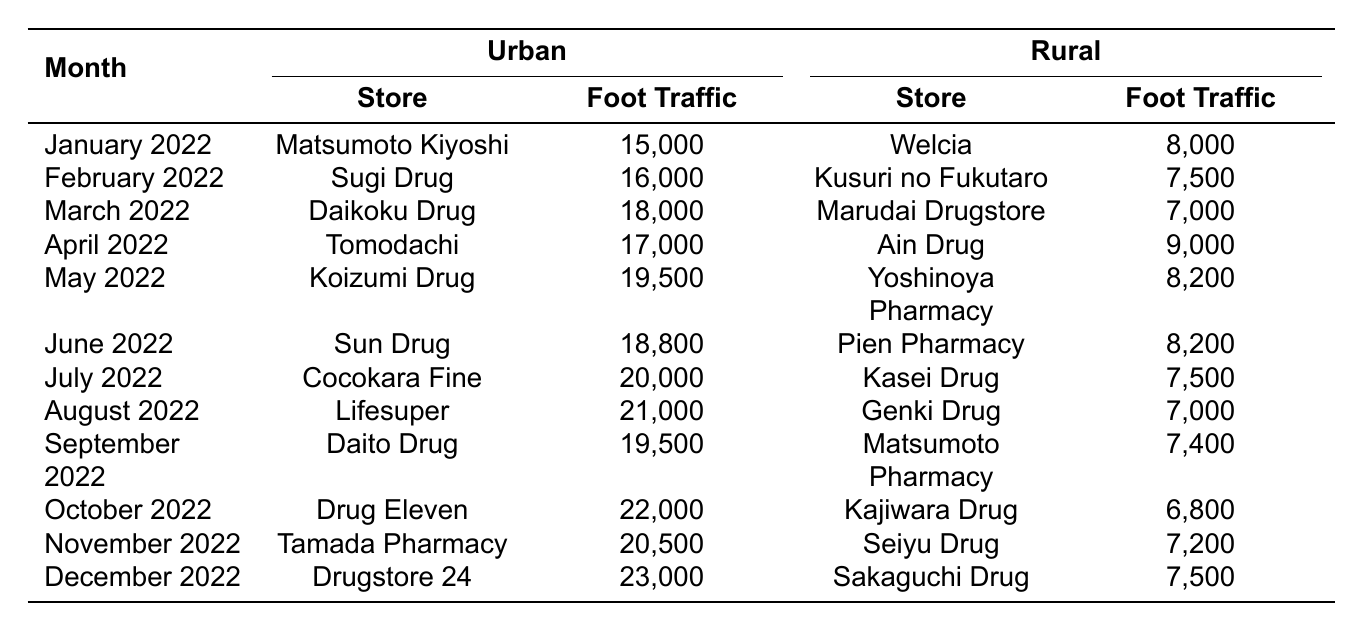What was the foot traffic of Cocokara Fine in July 2022? In the table, under July 2022 in the urban section, Cocokara Fine's foot traffic is listed as 20,000.
Answer: 20,000 Which rural drugstore had the highest foot traffic in December 2022? In December 2022, the rural drugstore Sakaguchi Drug had a foot traffic of 7,500, which is the highest for that month among rural stores listed.
Answer: Sakaguchi Drug What is the monthly foot traffic of Drug Eleven in October 2022 compared to Matsumoto Kiyoshi in January 2022? The foot traffic of Drug Eleven in October 2022 is 22,000, and Matsumoto Kiyoshi in January 2022 is 15,000. Comparing these two values: 22,000 is greater than 15,000.
Answer: 22,000 is greater What is the total rural foot traffic for all months combined? Adding the foot traffic of all rural drugstores: (8,000 + 7,500 + 7,000 + 9,000 + 8,200 + 8,200 + 7,500 + 7,000 + 7,400 + 6,800 + 7,200 + 7,500) equals 90,300.
Answer: 90,300 Which month had the greatest difference between urban and rural foot traffic? Calculating the differences month by month, we find that October 2022 had the highest difference: 22,000 (urban) - 6,800 (rural) = 15,200.
Answer: October 2022 Did any rural store exceed 9,000 foot traffic at any point in 2022? Checking each month's rural foot traffic, Ain Drug is the only rural store that exceeded 9,000 foot traffic in April 2022 with 9,000, but no other months surpassed this value.
Answer: No What was the average urban foot traffic from January to December 2022? The urban foot traffic values for all months are: (15,000 + 16,000 + 18,000 + 17,000 + 19,500 + 18,800 + 20,000 + 21,000 + 19,500 + 22,000 + 20,500 + 23,000) totals to  220,800. Dividing this amount by 12 gives an average of 18,400.
Answer: 18,400 What percentage increase in foot traffic did Lifesuper experience from August to September 2022? Lifesuper had 21,000 in August and Daito Drug in September had 19,500. The difference is 21,000 - 19,500 = 1,500. The percentage increase is calculated as (1,500/21,000) * 100, which is approximately 7.14%.
Answer: Approximately 7.14% Which urban store had consistent foot traffic above 15,000 for every month? By analyzing the table, it can be seen that Urban stores maintained foot traffic above 15,000 consistently starting from January through to December; only one store (Matsumoto Kiyoshi) had foot traffic below 15,000.
Answer: Yes, multiple stores did 